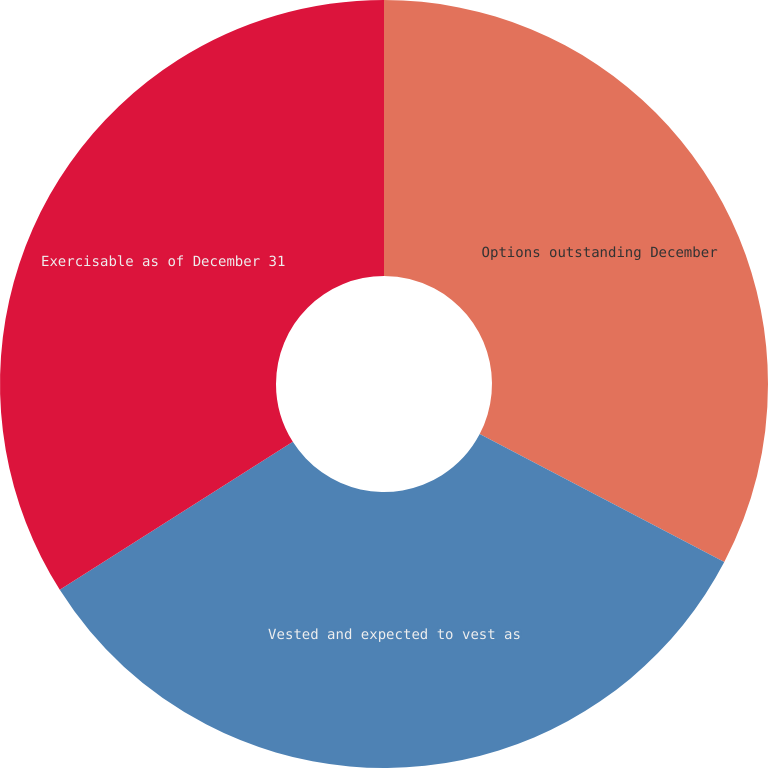Convert chart. <chart><loc_0><loc_0><loc_500><loc_500><pie_chart><fcel>Options outstanding December<fcel>Vested and expected to vest as<fcel>Exercisable as of December 31<nl><fcel>32.67%<fcel>33.33%<fcel>34.0%<nl></chart> 